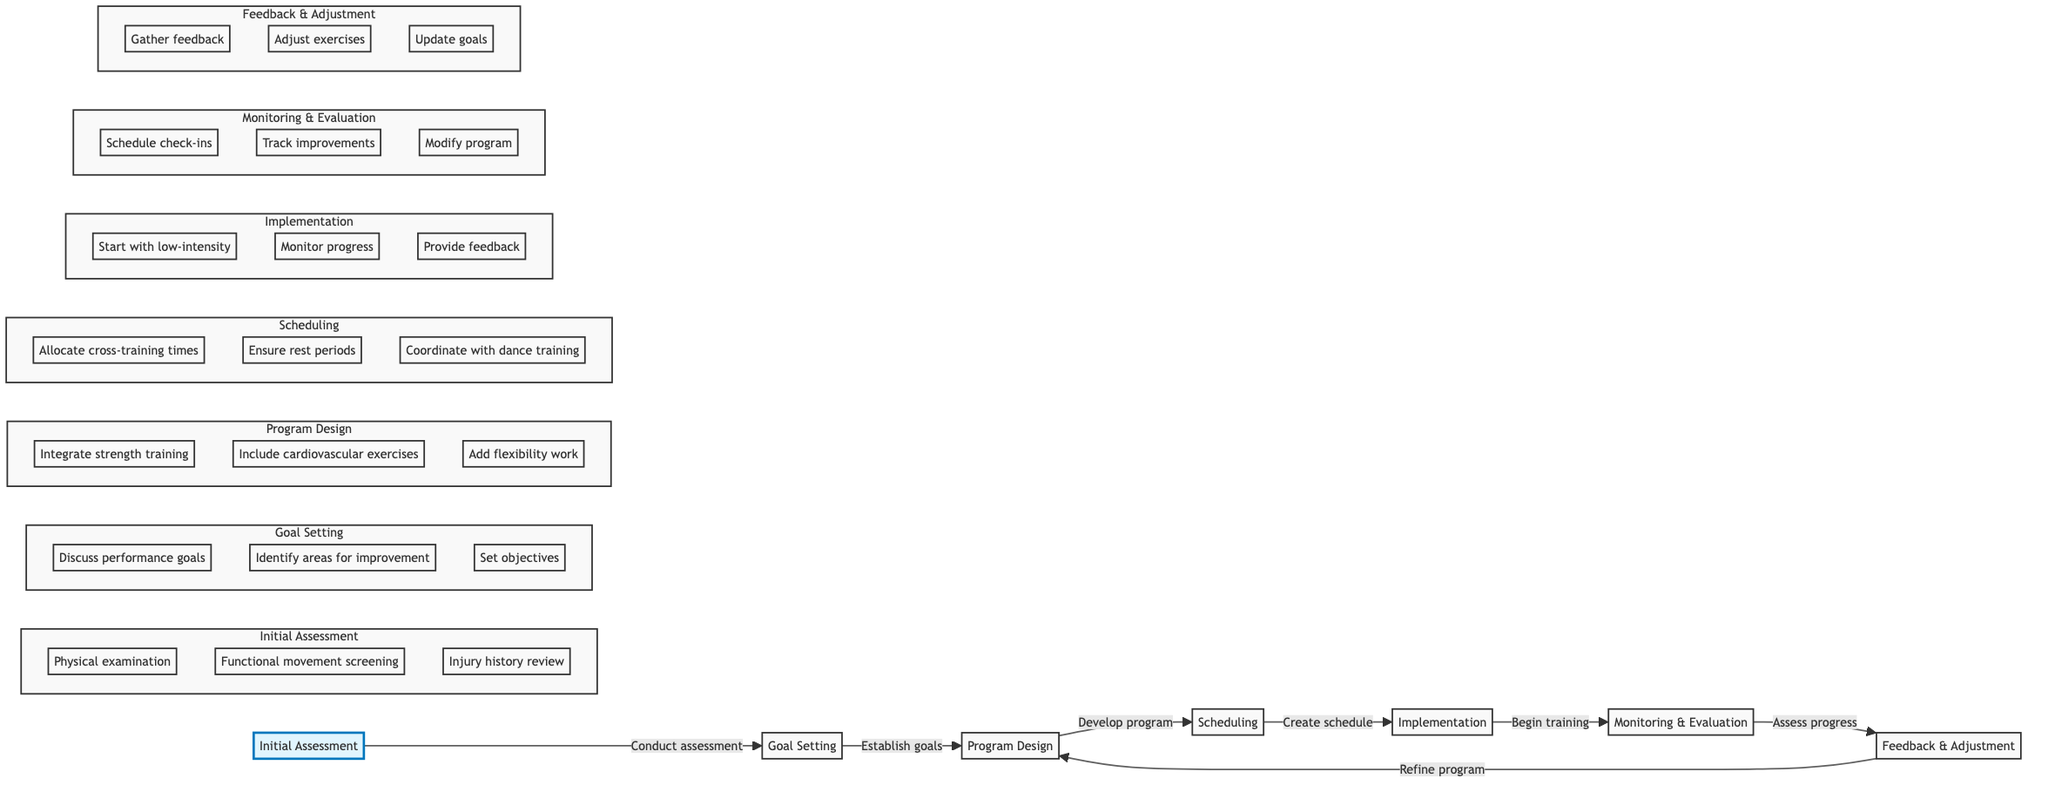What is the first step in the cross-training process? The diagram indicates that the first step to initiate the cross-training process is "Initial Assessment." This is connected as the starting node in the flowchart.
Answer: Initial Assessment How many main steps are there in the process? By counting the individual nodes connected in the horizontal flowchart, there are a total of seven main steps: Initial Assessment, Goal Setting, Program Design, Scheduling, Implementation, Monitoring & Evaluation, and Feedback & Adjustment.
Answer: Seven What are two actions included in the 'Program Design' step? The 'Program Design' step includes several actions, and two of them listed are "Integrate strength training" and "Include cardiovascular exercises." These are part of the actions detailed for this node.
Answer: Integrate strength training, Include cardiovascular exercises Which step follows 'Scheduling' in the diagram? According to the flowchart, the step that directly follows 'Scheduling' is 'Implementation.' The arrows indicate the flow from one step to the next, showing the progression.
Answer: Implementation What is the purpose of the 'Monitoring & Evaluation' step? The objective of the 'Monitoring & Evaluation' step is to "Regularly assess the dancers' progress towards their goals and make necessary adjustments to the program." This is the described function of this node in the chart.
Answer: Regularly assess the dancers' progress How does the 'Feedback & Adjustment' step relate to 'Program Design'? The flowchart shows that 'Feedback & Adjustment' connects back to 'Program Design', indicating a cyclical relationship where the feedback gained is used to refine and adjust the cross-training program.
Answer: Connects back to 'Program Design' What is an essential action when 'Implementation' begins? One essential action mentioned in the 'Implementation' step is to "Start with low-intensity exercises to build a foundation." This indicates the recommended approach at the beginning of this stage.
Answer: Start with low-intensity exercises 